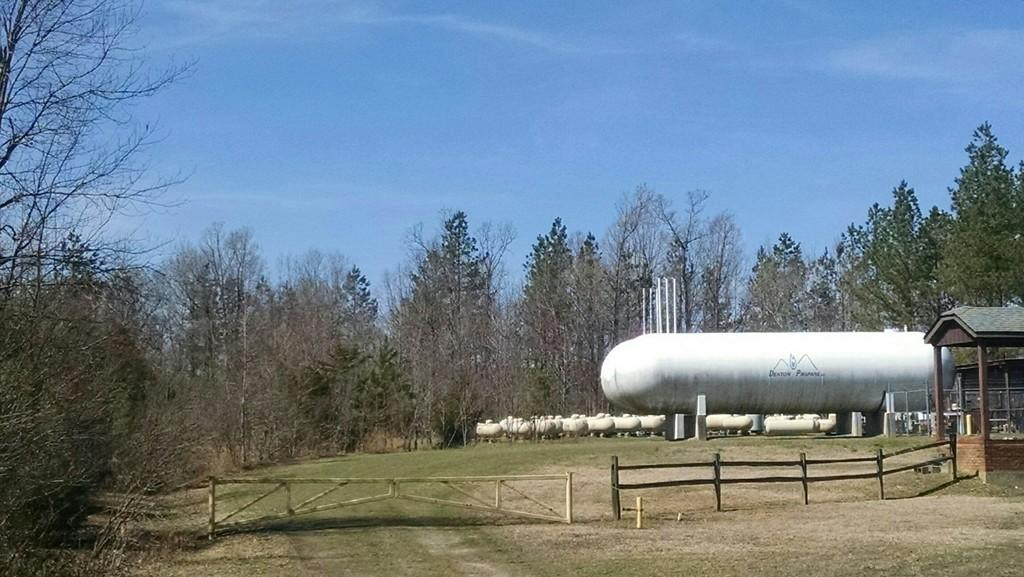What type of vehicles are present in the image? There are tankers in the image. What type of structures can be seen in the image? There are sheds in the image. What type of barriers are present in the image? There are fences in the image. What type of vertical structures are present in the image? There are poles in the image. What can be seen in the background of the image? There is a road visible in the background of the image. What is visible at the top of the image? The sky is visible at the top of the image. What type of texture can be seen on the plate in the image? There is no plate present in the image, so it is not possible to determine the texture. 